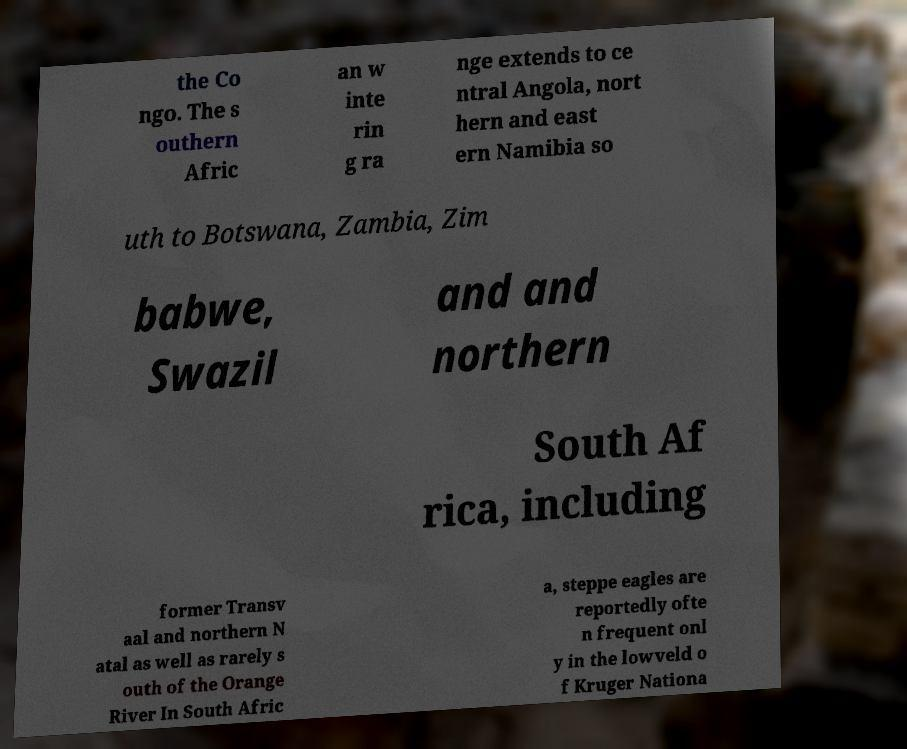There's text embedded in this image that I need extracted. Can you transcribe it verbatim? the Co ngo. The s outhern Afric an w inte rin g ra nge extends to ce ntral Angola, nort hern and east ern Namibia so uth to Botswana, Zambia, Zim babwe, Swazil and and northern South Af rica, including former Transv aal and northern N atal as well as rarely s outh of the Orange River In South Afric a, steppe eagles are reportedly ofte n frequent onl y in the lowveld o f Kruger Nationa 